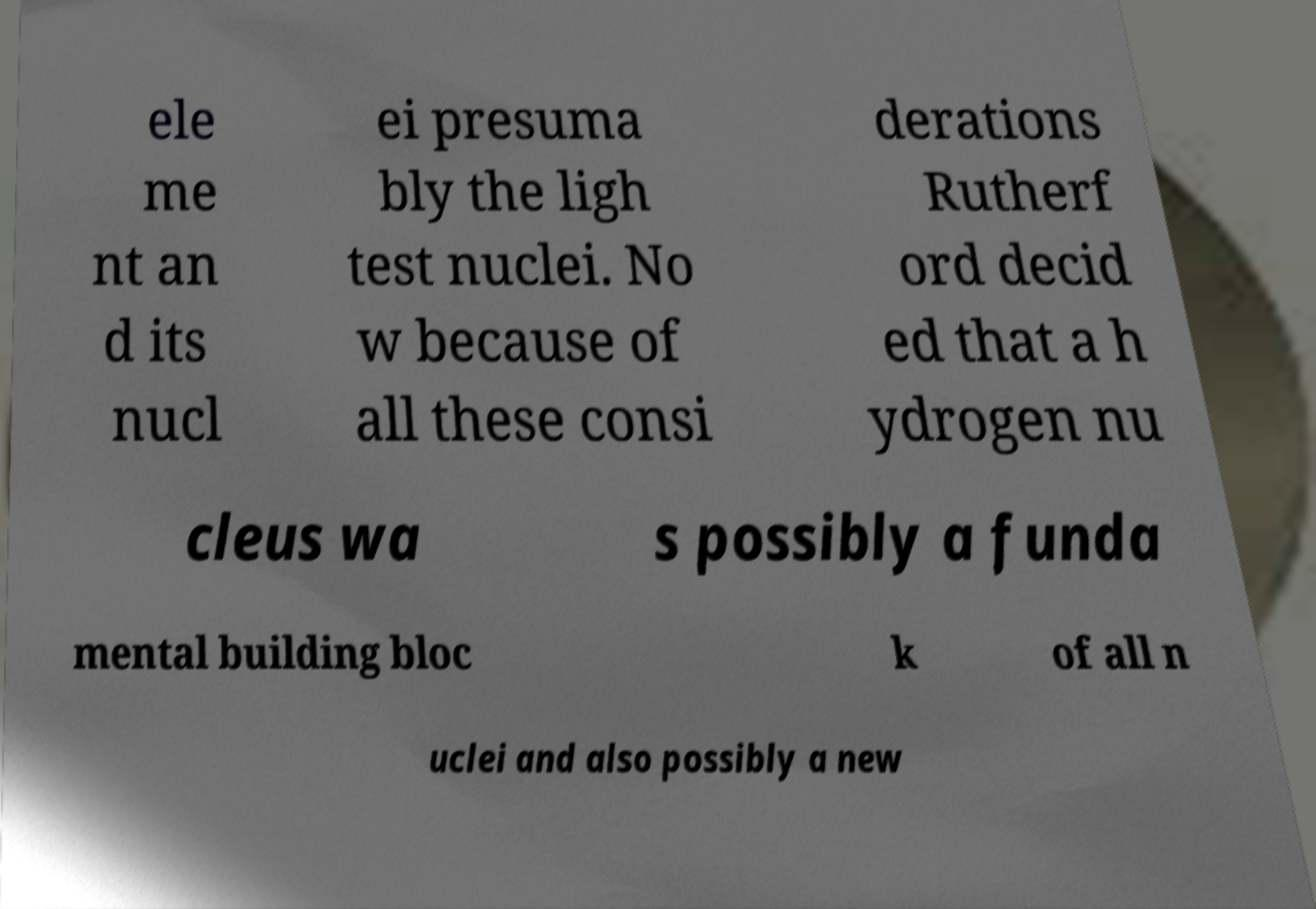Can you read and provide the text displayed in the image?This photo seems to have some interesting text. Can you extract and type it out for me? ele me nt an d its nucl ei presuma bly the ligh test nuclei. No w because of all these consi derations Rutherf ord decid ed that a h ydrogen nu cleus wa s possibly a funda mental building bloc k of all n uclei and also possibly a new 